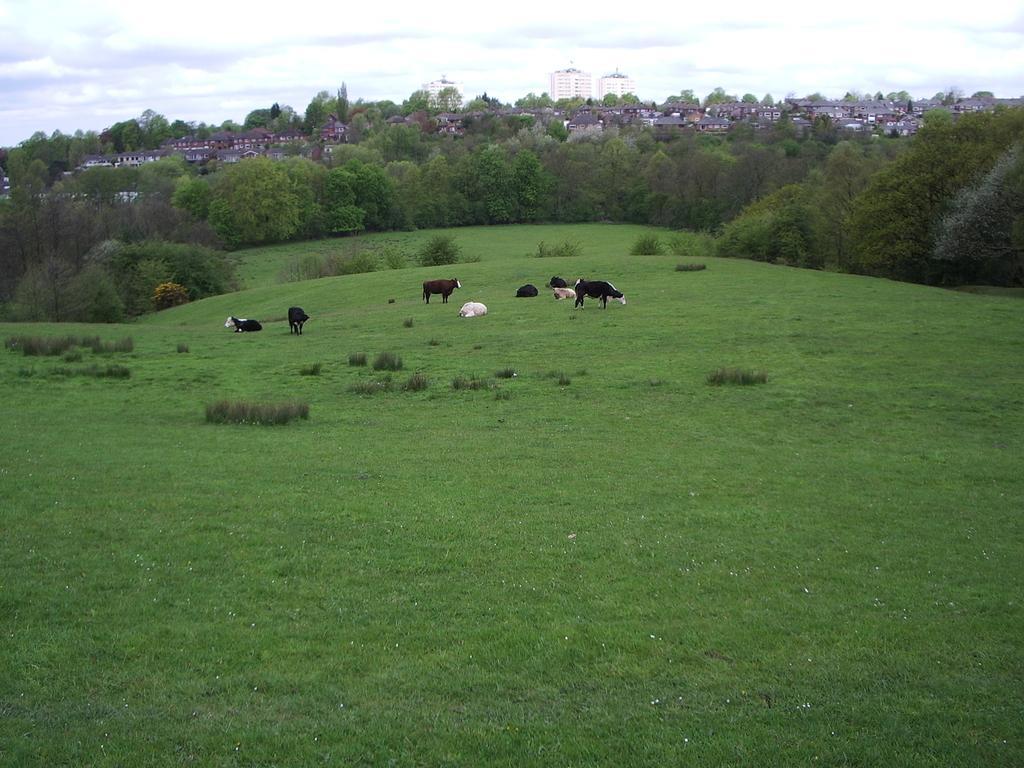How would you summarize this image in a sentence or two? In this image in the center there are some cows, and at the bottom there is grass and some plants and in the background there are some buildings and trees. At the top there is sky. 